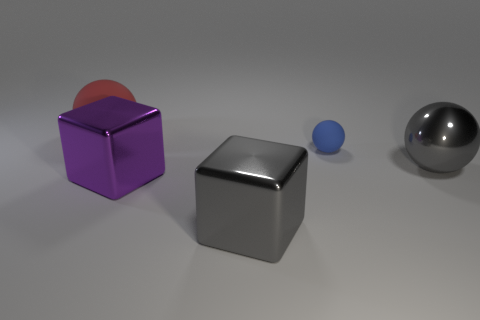What could these objects represent in a symbolic way? Symbolically, these objects might represent different aspects of diversity and uniqueness. The various shapes, sizes, and materials could symbolize how distinct individuals or ideas contribute to a complex and harmonious society. Just as these objects coexist without overshadowing each other, they can serve as a metaphor for the strength found in diversity. 